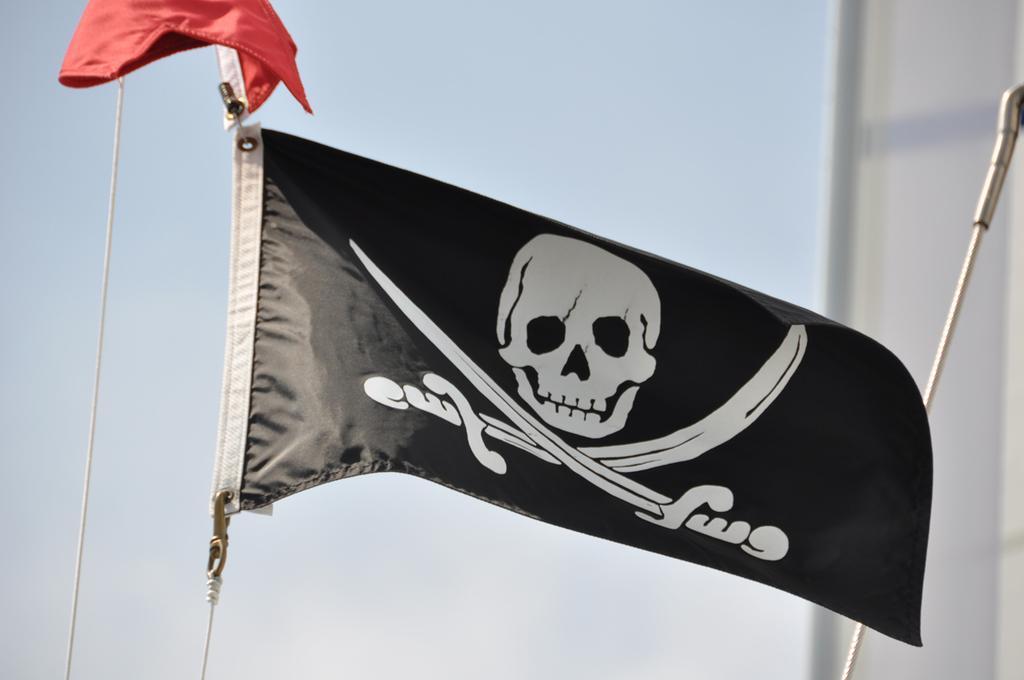How would you summarize this image in a sentence or two? The picture consists of a pirate flag and rope. The background is blurred. It is sunny. 